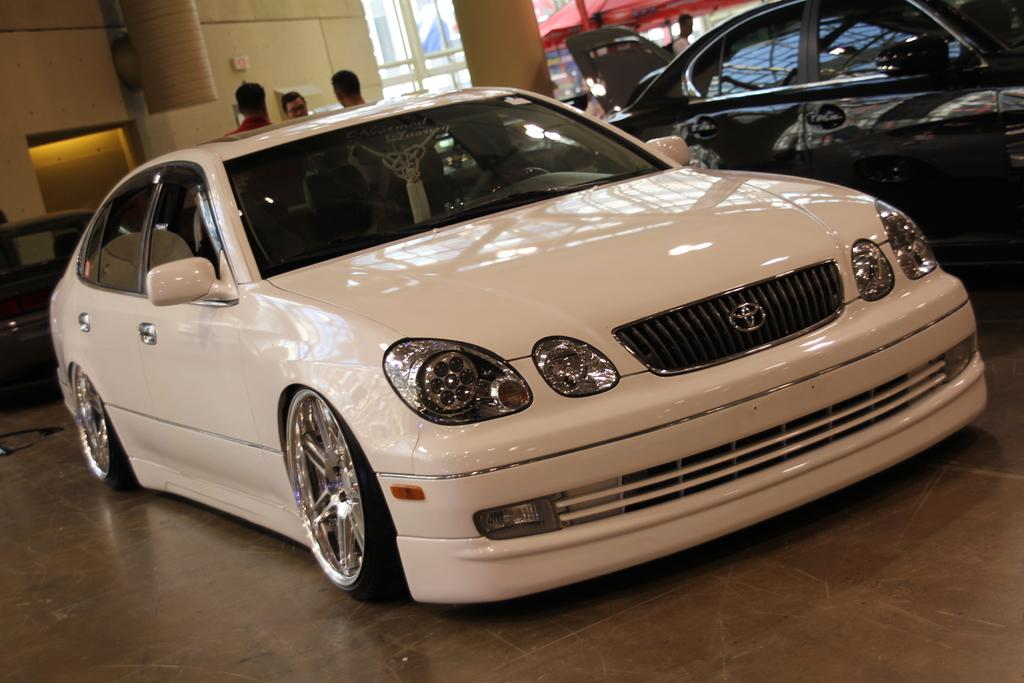What is the main subject in the center of the image? There is a car in the center of the image. Are there any other cars visible in the image? Yes, there are other cars on the right side and the left side of the image. Can you describe the background of the image? There are people in the background of the image. What type of rifle can be seen in the image? There is no rifle present in the image. What kind of food is being served in the front of the image? There is no food visible in the image. 